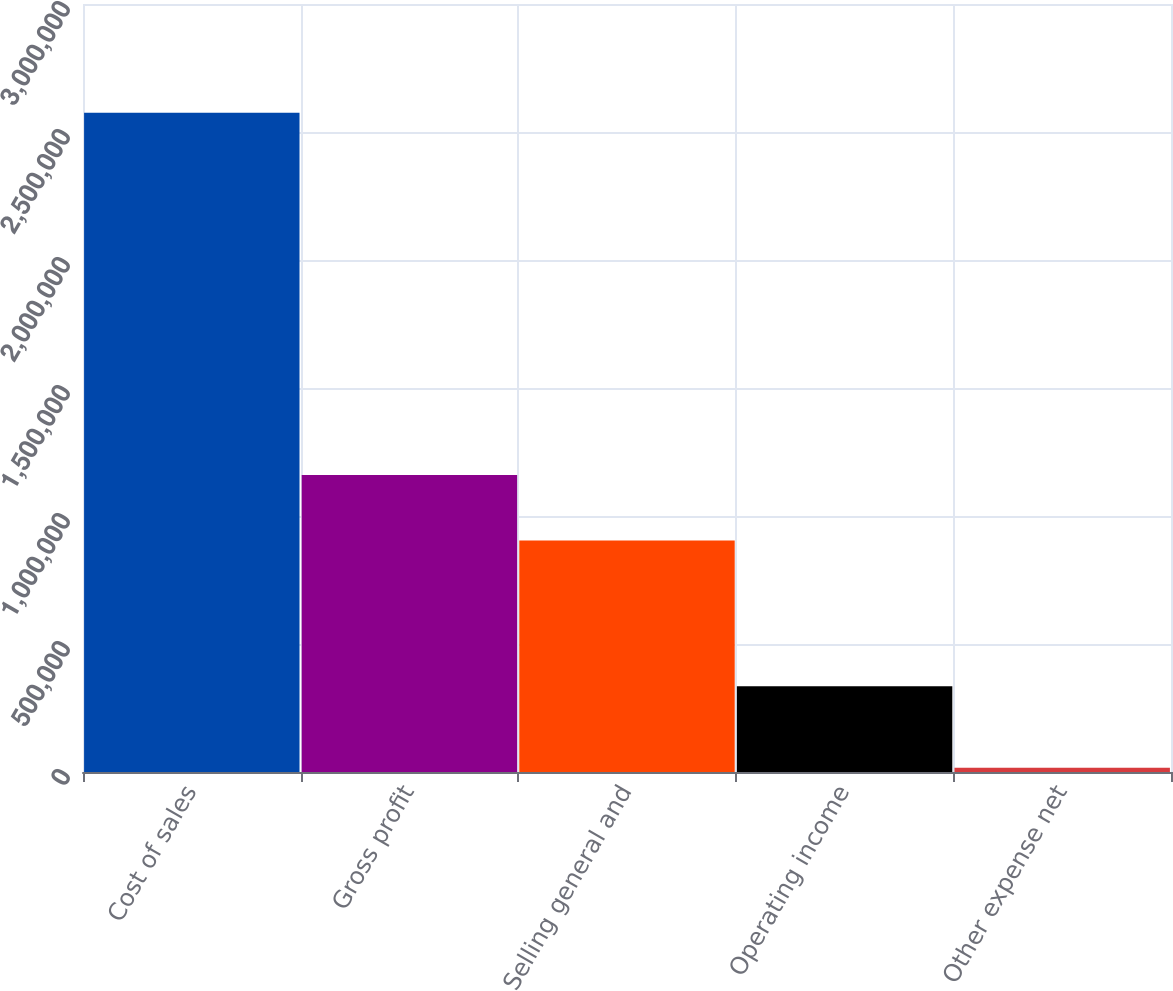Convert chart to OTSL. <chart><loc_0><loc_0><loc_500><loc_500><bar_chart><fcel>Cost of sales<fcel>Gross profit<fcel>Selling general and<fcel>Operating income<fcel>Other expense net<nl><fcel>2.57545e+06<fcel>1.1598e+06<fcel>903864<fcel>335422<fcel>16114<nl></chart> 